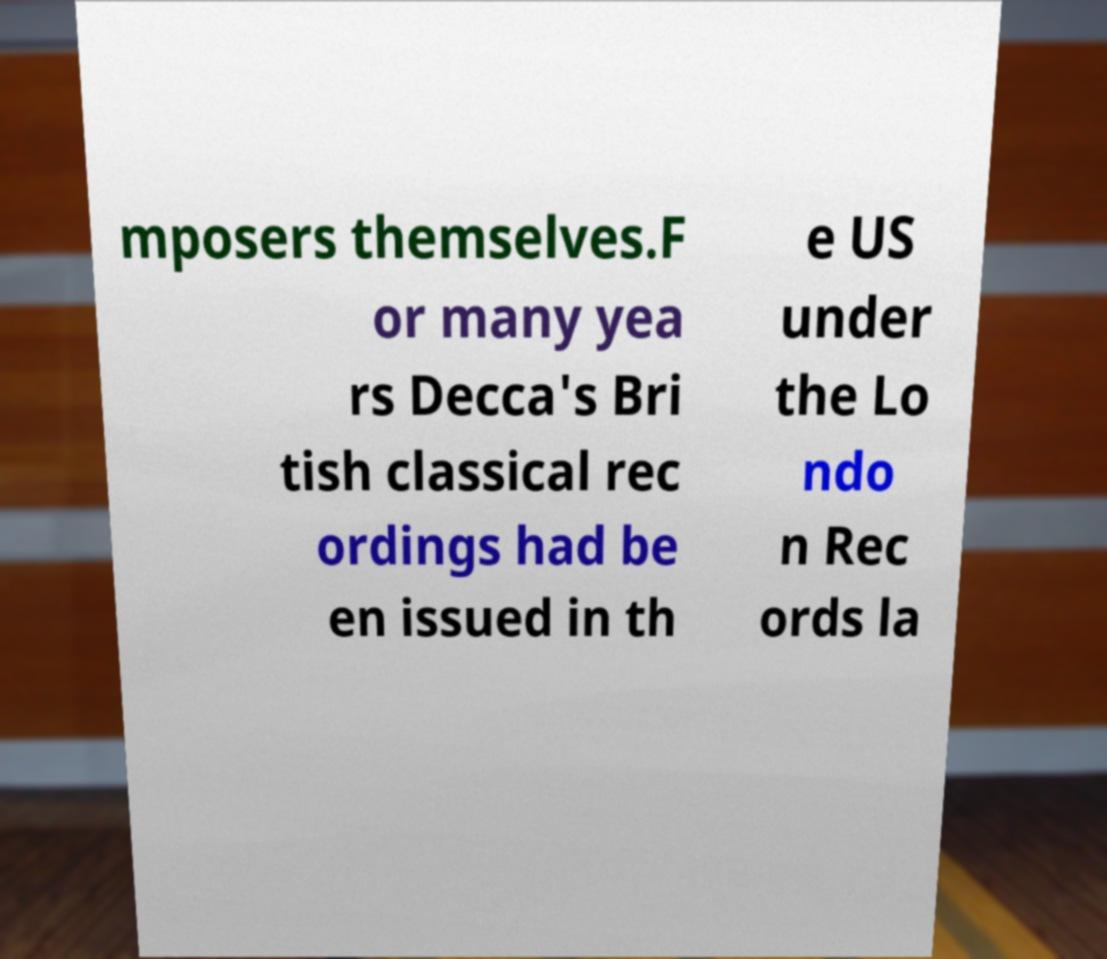There's text embedded in this image that I need extracted. Can you transcribe it verbatim? mposers themselves.F or many yea rs Decca's Bri tish classical rec ordings had be en issued in th e US under the Lo ndo n Rec ords la 